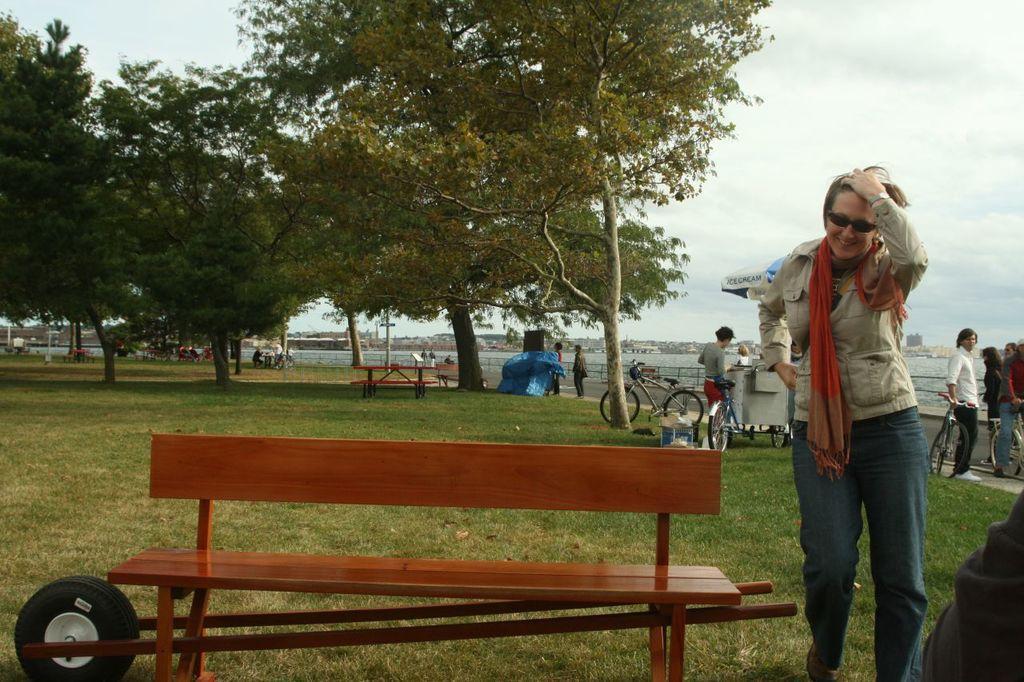Please provide a concise description of this image. On the right there is a woman she wear short ,scarf ,shades and trouser ,she is smiling. In the middle there is a bench. In the right there are many people and cycles. In the background there are trees,bench ,water ,sky and clouds. 